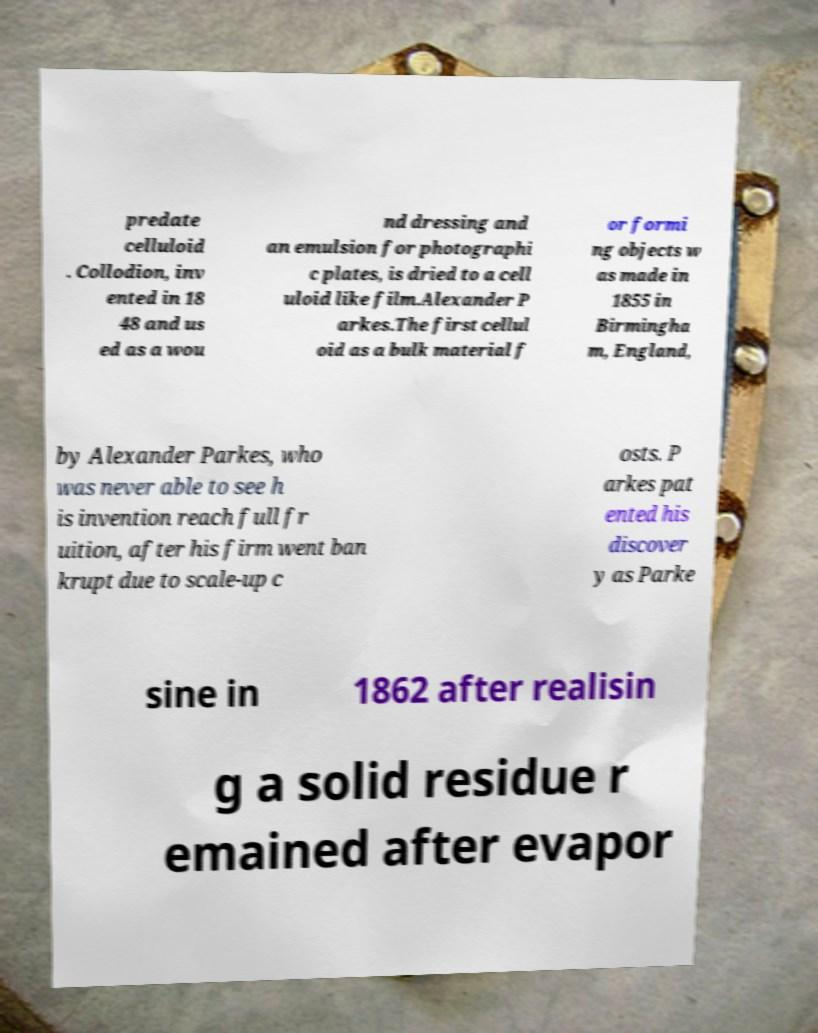I need the written content from this picture converted into text. Can you do that? predate celluloid . Collodion, inv ented in 18 48 and us ed as a wou nd dressing and an emulsion for photographi c plates, is dried to a cell uloid like film.Alexander P arkes.The first cellul oid as a bulk material f or formi ng objects w as made in 1855 in Birmingha m, England, by Alexander Parkes, who was never able to see h is invention reach full fr uition, after his firm went ban krupt due to scale-up c osts. P arkes pat ented his discover y as Parke sine in 1862 after realisin g a solid residue r emained after evapor 